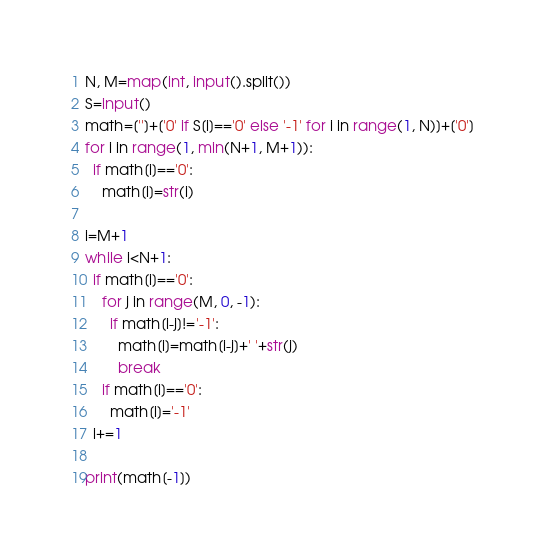Convert code to text. <code><loc_0><loc_0><loc_500><loc_500><_Python_>N, M=map(int, input().split())
S=input()
math=['']+['0' if S[i]=='0' else '-1' for i in range(1, N)]+['0']
for i in range(1, min(N+1, M+1)):
  if math[i]=='0':
    math[i]=str(i)
    
i=M+1
while i<N+1:
  if math[i]=='0':
    for j in range(M, 0, -1):
      if math[i-j]!='-1':
        math[i]=math[i-j]+' '+str(j)      
        break
    if math[i]=='0':
      math[i]='-1'
  i+=1
  
print(math[-1])</code> 